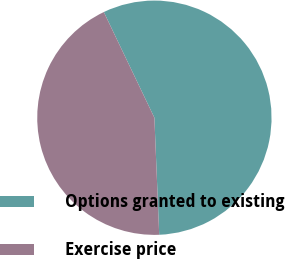Convert chart. <chart><loc_0><loc_0><loc_500><loc_500><pie_chart><fcel>Options granted to existing<fcel>Exercise price<nl><fcel>56.45%<fcel>43.55%<nl></chart> 